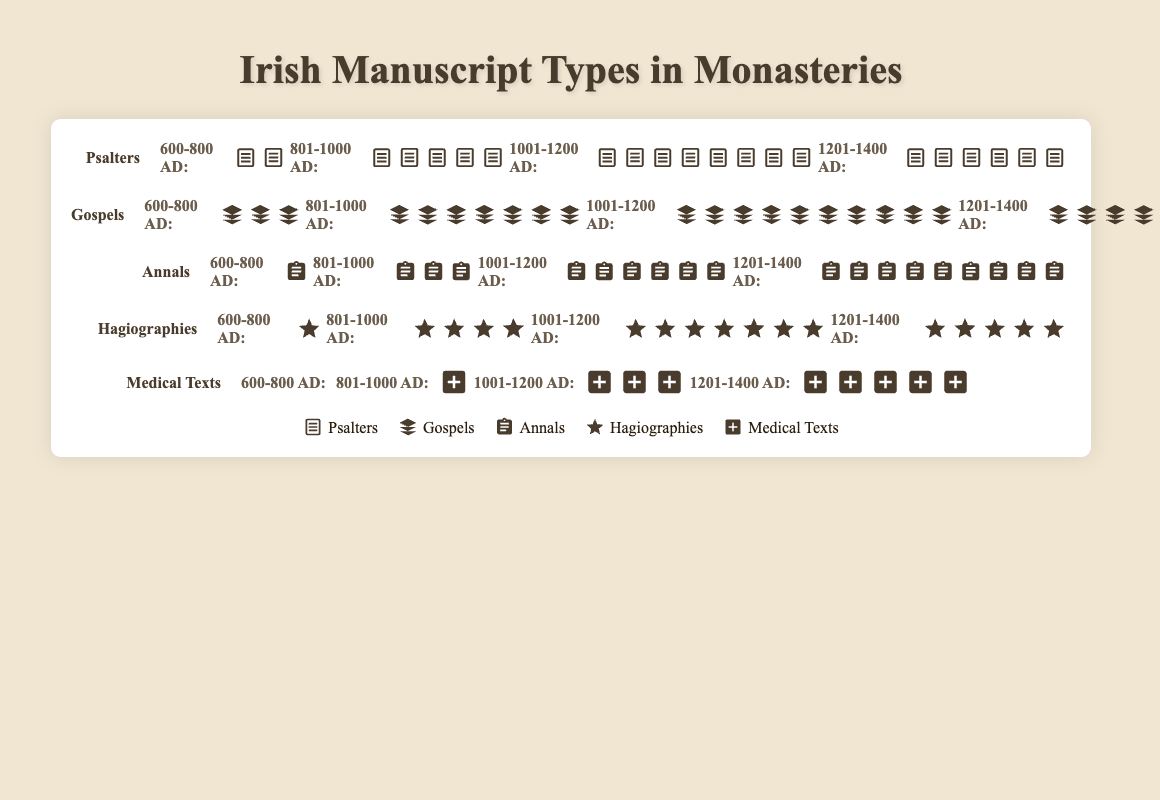Which manuscript type had the highest count in the 1001-1200 AD time period? Reviewing the bar for each manuscript type under the 1001-1200 AD period, **Gospels** had the most icons.
Answer: Gospels How many total Hagiographies were found across all time periods? Summing up Hagiographies counts from each period: 1 (600-800 AD) + 4 (801-1000 AD) + 7 (1001-1200 AD) + 5 (1201-1400 AD) = 17
Answer: 17 Which time period had the fewest total manuscripts? For each period, sum the numbers of manuscripts: 
600-800 AD: 2 + 3 + 1 + 1 + 0 = 7 
801-1000 AD: 5 + 7 + 3 + 4 + 1 = 20 
1001-1200 AD: 8 + 10 + 6 + 7 + 3 = 34 
1201-1400 AD: 6 + 4 + 9 + 5 + 5 = 29
The 600-800 AD period had the fewest manuscripts.
Answer: 600-800 AD How did the count of Medical Texts change from the 600-800 AD to the 1201-1400 AD period? From the 600-800 AD period (0) to the 1201-1400 AD period (5), Medical Texts increased by 5.
Answer: Increased by 5 Which manuscript type showed consistent growth across all time periods? Reviewing the icons for each type, **Annals** grew consistently: 1 (600-800 AD), 3 (801-1000 AD), 6 (1001-1200 AD), 9 (1201-1400 AD).
Answer: Annals Between Psalters and Gospels, which type had more manuscripts in the 801-1000 AD period? Comparing icons in the 801-1000 AD period, Gospels (7) had more manuscripts than Psalters (5).
Answer: Gospels What was the most common manuscript type found during the 801-1000 AD period? During the 801-1000 AD period, **Gospels** had the highest count (7).
Answer: Gospels How many total manuscripts were there in the 1201-1400 AD period? Summing the counts of all types: Psalters (6), Gospels (4), Annals (9), Hagiographies (5), Medical Texts (5) gives a total of 6 + 4 + 9 + 5 + 5 = 29.
Answer: 29 